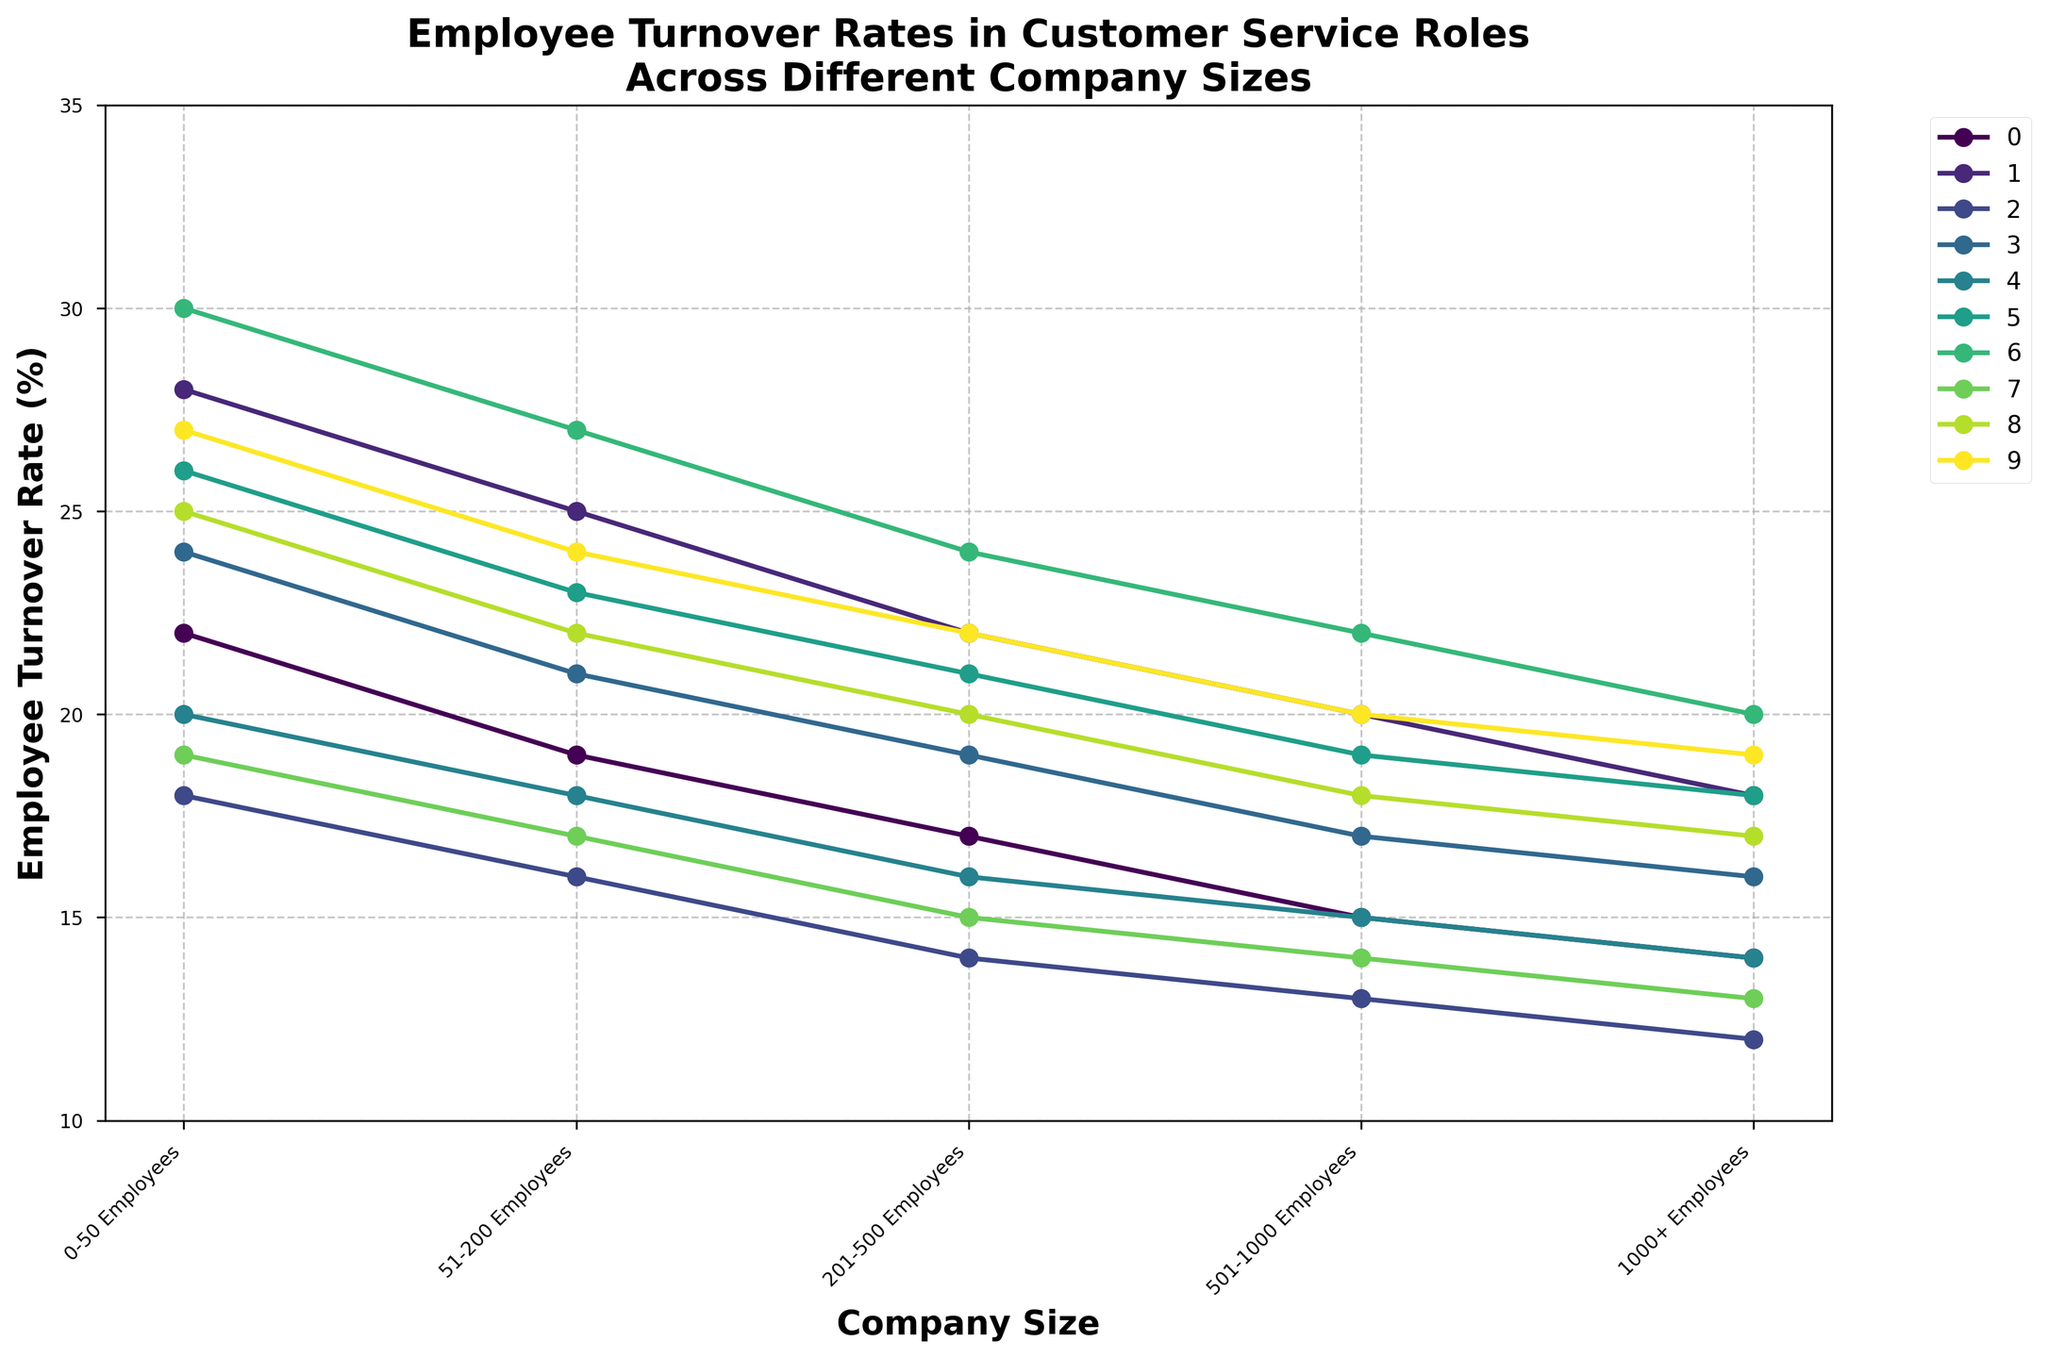What is the turnover rate for Local Coffee Shops with 201-500 employees? Find the line labeled "Local Coffee Shops" and then trace it to the point above the "201-500 Employees" category.
Answer: 24% Which company size has the highest employee turnover rate for Neighborhood Pharmacies? Identify the line for Neighborhood Pharmacies and look for the highest point among the plotted points.
Answer: 0-50 Employees Which company type has the smallest overall turnover rate for a 1000+ employee company? Compare the points above the "1000+ Employees" category across all lines. Identify the line with the lowest turnover rate.
Answer: Regional Banks How much does the turnover rate for Small Retail Stores decrease from 0-50 to 201-500 employees? For Small Retail Stores, subtract the turnover rate at "201-500 Employees" from the turnover rate at "0-50 Employees" (22% - 17%).
Answer: 5% Which two company types have equal turnover rates for businesses with 1000+ employees? Look at the "1000+ Employees" category and find two lines which terminate at the same point.
Answer: Independent Bookstores and Small Retail Stores By what percentage do Local Restaurants reduce turnover rates from the smallest to the largest company size? For Local Restaurants, subtract the turnover rate at "1000+ Employees" from the turnover rate at "0-50 Employees" (28% - 18%).
Answer: 10% Among Small Tech Startups and Boutique Hotels, which has a lower turnover rate for 201-500 employees, and by how much? Compare the turnover rates at "201-500 Employees" for both lines. Subtract the smaller from the larger.
Answer: Small Tech Startups, by 1% What is the average turnover rate for Family-owned Groceries across all company sizes? Add all turnover rates for Family-owned Groceries and divide by the number of company sizes ((26% + 23% + 21% + 19% + 18%) / 5).
Answer: 21.4% If you combine the turnover rates for Local Fitness Centers and Local Coffee Shops at the 51-200 employees size, what will it be? Add the turnover rates for Local Fitness Centers and Local Coffee Shops at "51-200 Employees" (24% + 27%).
Answer: 51% 